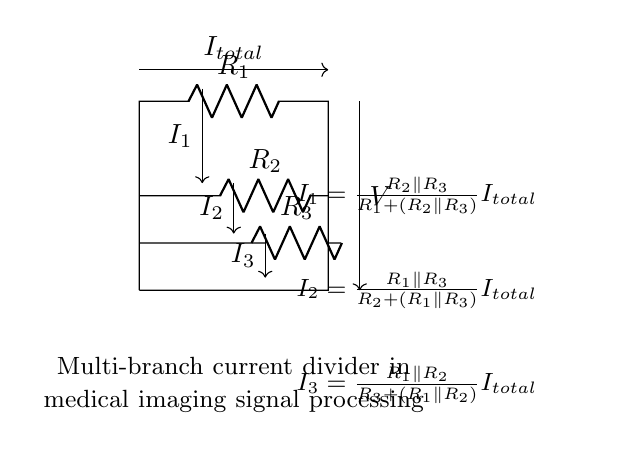What are the resistances in the circuit? The circuit contains three resistances labeled as R1, R2, and R3. Each resistance influences the current distribution among the branches according to their values.
Answer: R1, R2, R3 What is the total current flowing through the circuit? The total current, labeled as Itotal, is represented by the arrow indicating direction flowing into the circuit from the top. It's measured at the input before the current divides among the branches.
Answer: Itotal What relationship dictates the distribution of the total current in the circuit? The distribution of the total current is dictated by the resistive values of R1, R2, and R3 and the concept of current division, whereby the current flows inversely proportional to the resistance values in the respective branches.
Answer: Current division How would increasing R1 affect I2? Increasing R1 would decrease I2 since the total resistance seen by the source increases, reducing the overall current. As per the current divider rule, if one branch resistance increases, the current through that branch will decrease.
Answer: Decrease What is the effect of parallel resistors on the total current? The parallel resistors R2 and R3 reduce the overall resistance seen by the total current, thereby allowing more current to flow through the branches compared to a series configuration, affecting the distribution of currents I1, I2, and I3.
Answer: Increase current flow What determines the voltage across each resistor? The voltage across each resistor is determined by the current flowing through it and its resistance, described by Ohm's Law (V=IR). In a multi-branch circuit like this, the branch resistances and the current division influence the individual voltages across each resistor.
Answer: Current and resistance 